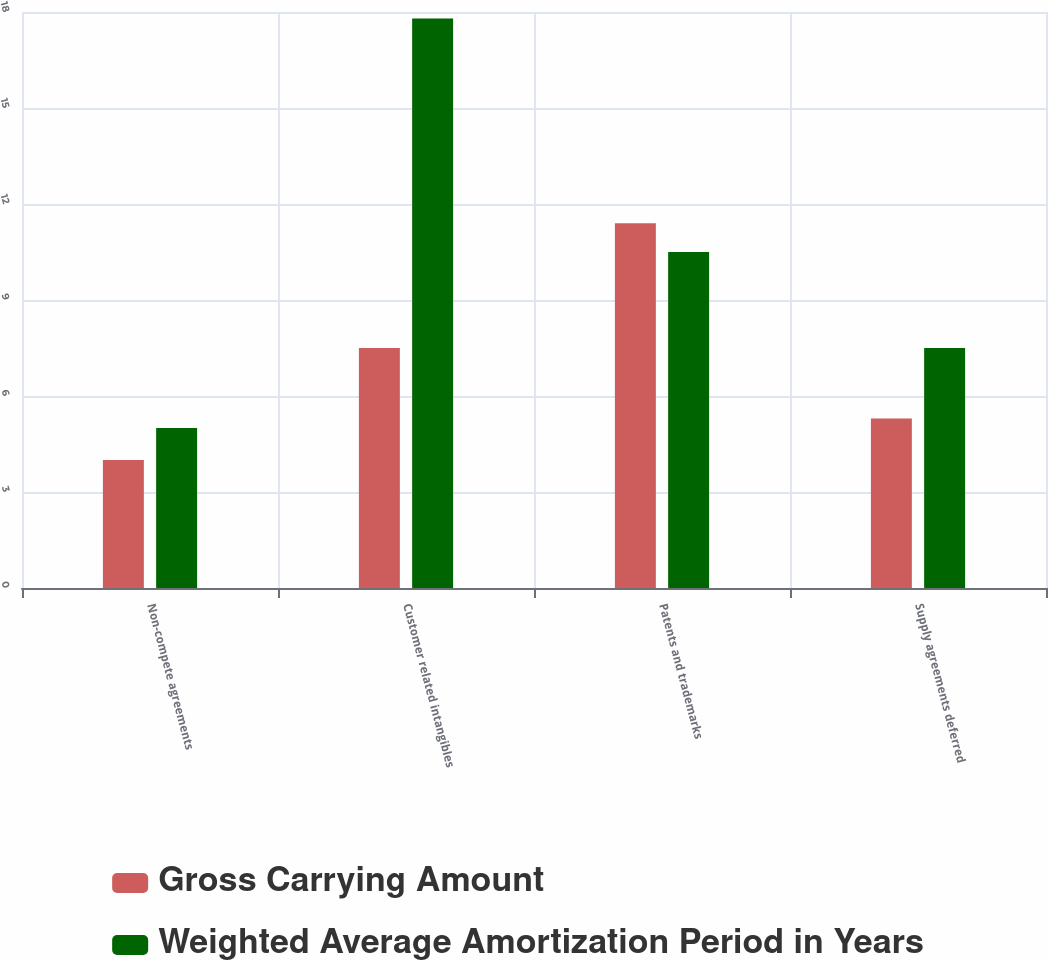<chart> <loc_0><loc_0><loc_500><loc_500><stacked_bar_chart><ecel><fcel>Non-compete agreements<fcel>Customer related intangibles<fcel>Patents and trademarks<fcel>Supply agreements deferred<nl><fcel>Gross Carrying Amount<fcel>4<fcel>7.5<fcel>11.4<fcel>5.3<nl><fcel>Weighted Average Amortization Period in Years<fcel>5<fcel>17.8<fcel>10.5<fcel>7.5<nl></chart> 